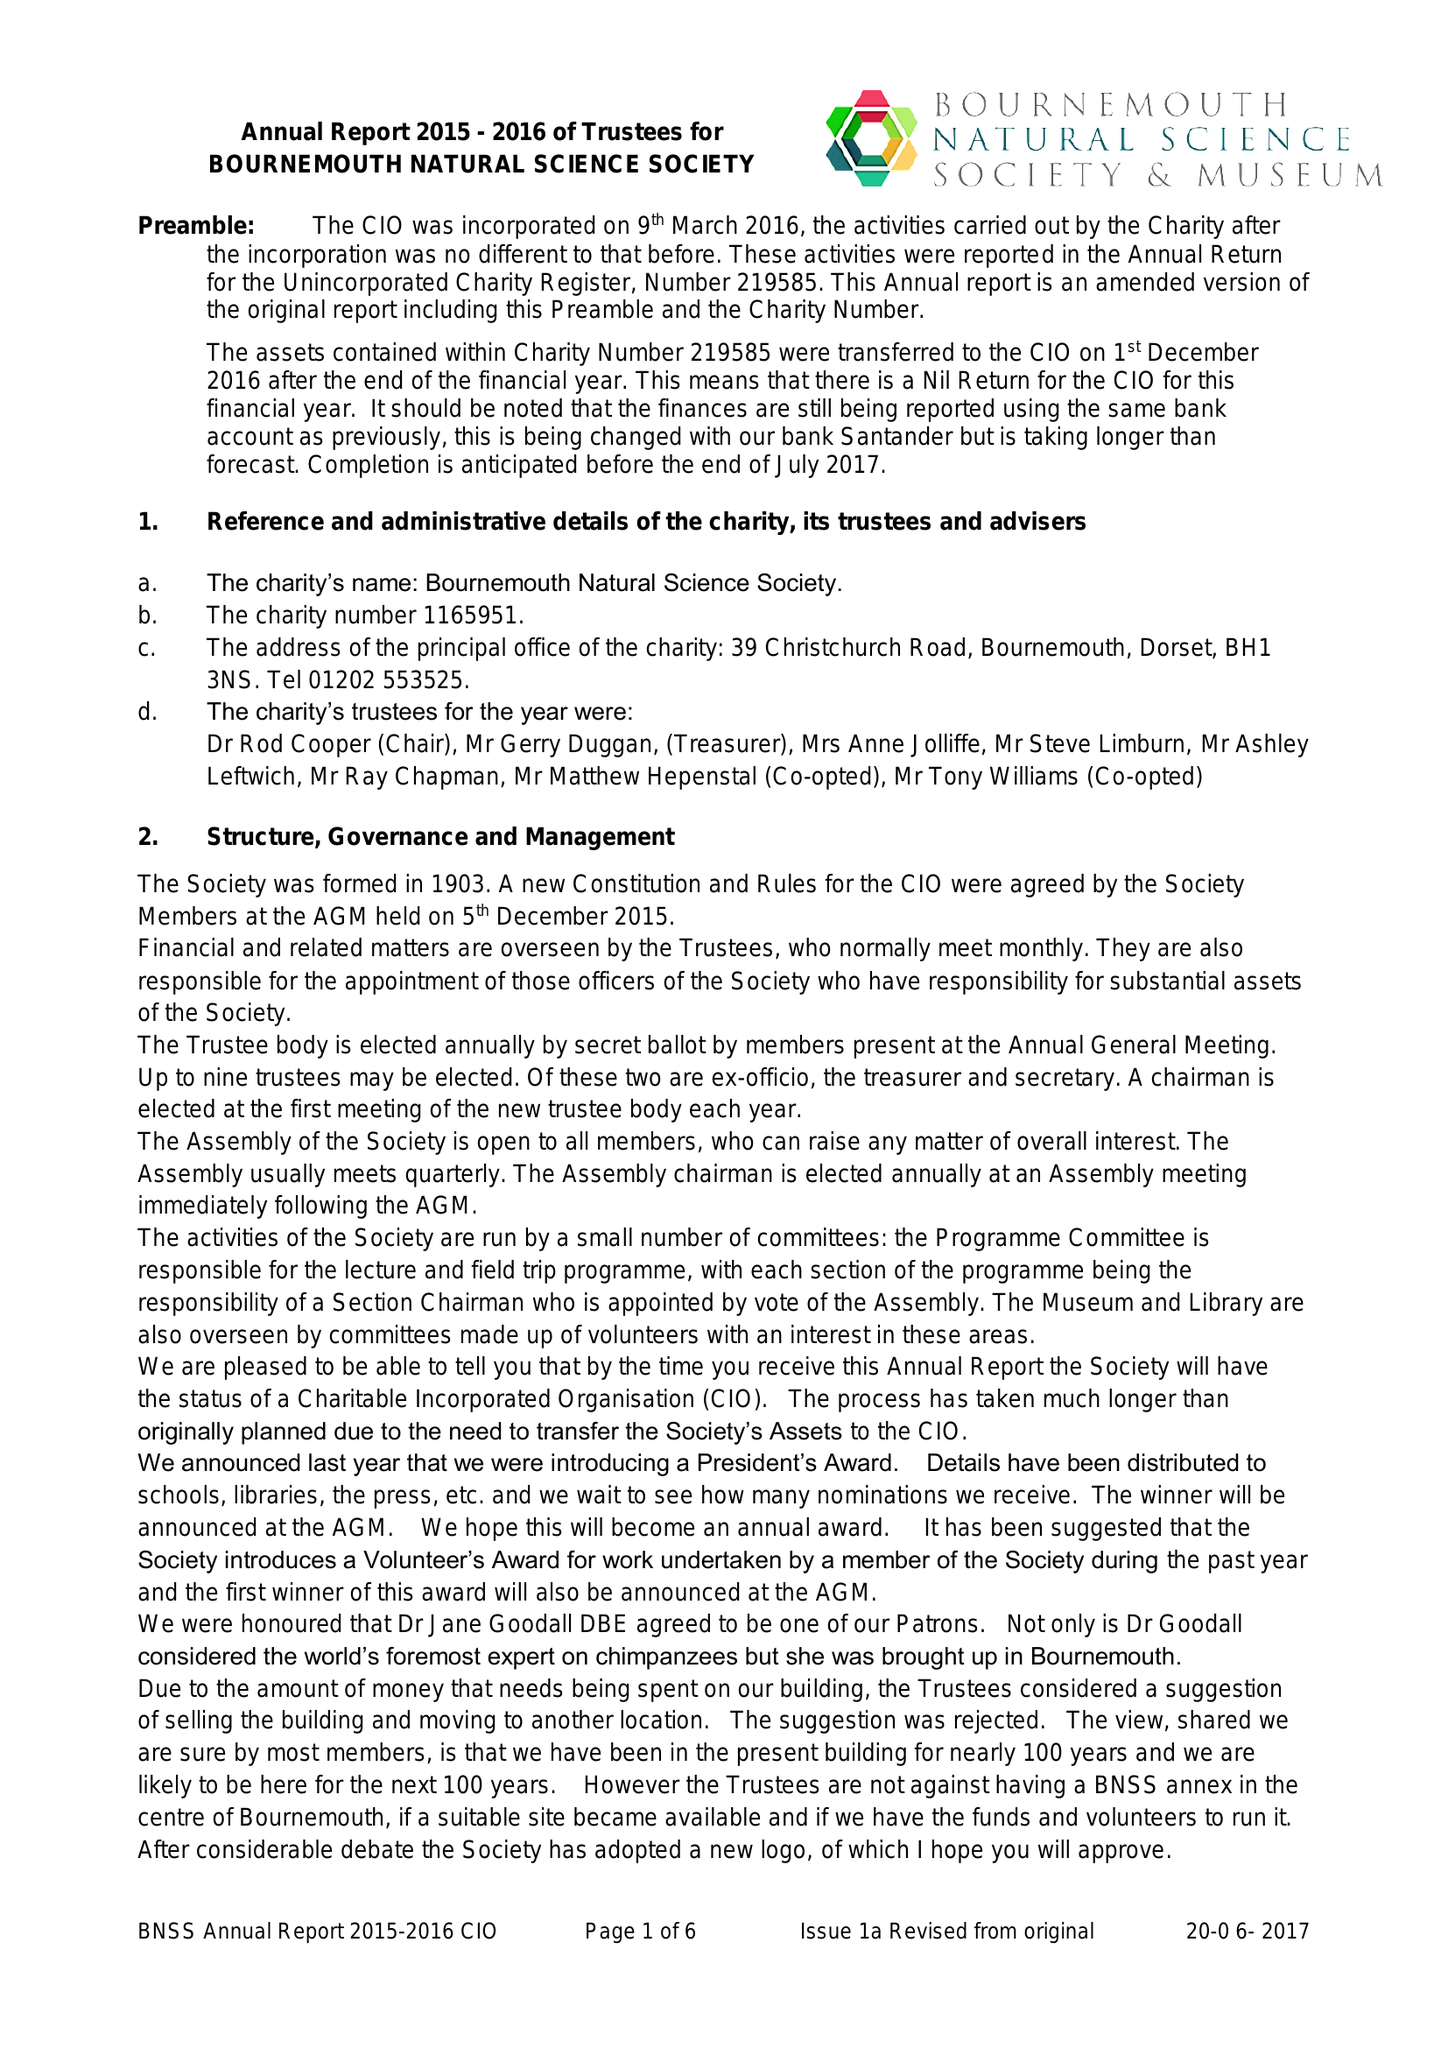What is the value for the address__street_line?
Answer the question using a single word or phrase. 39 CHRISTCHURCH ROAD 